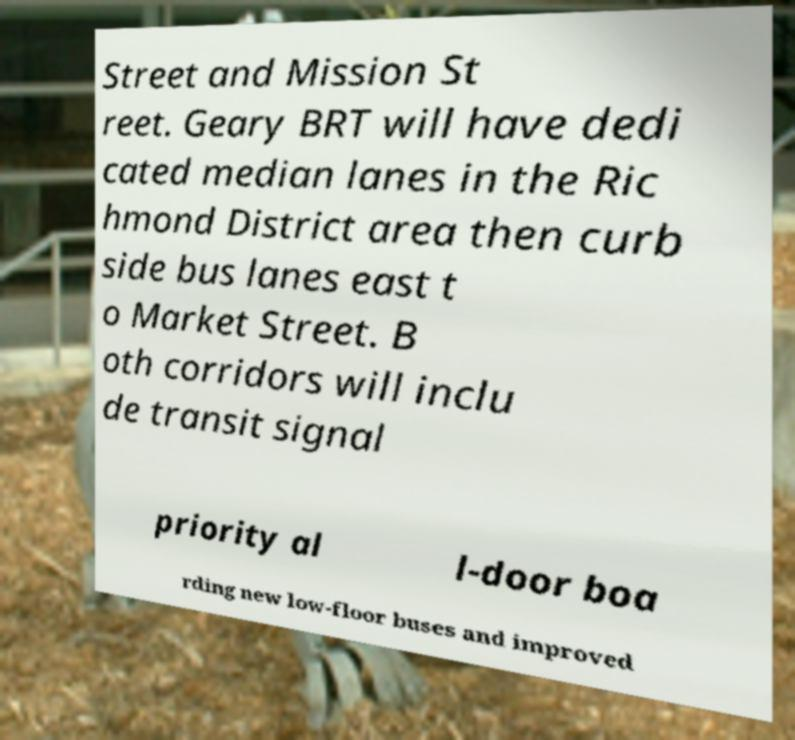Please identify and transcribe the text found in this image. Street and Mission St reet. Geary BRT will have dedi cated median lanes in the Ric hmond District area then curb side bus lanes east t o Market Street. B oth corridors will inclu de transit signal priority al l-door boa rding new low-floor buses and improved 